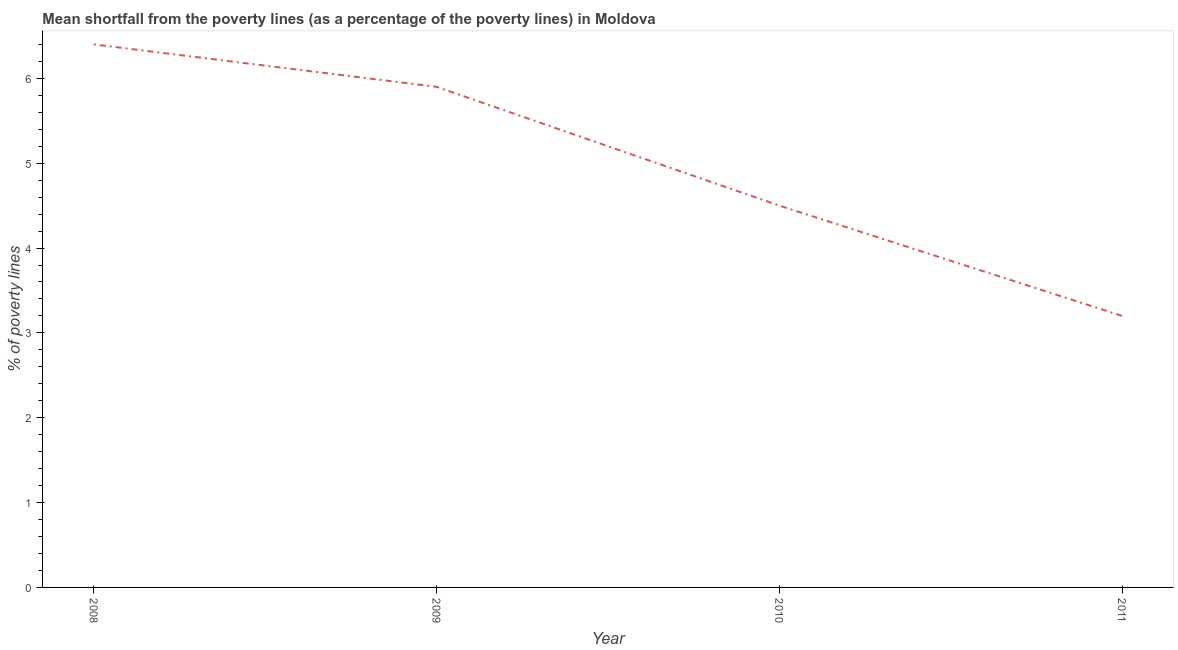What is the poverty gap at national poverty lines in 2010?
Make the answer very short. 4.5. What is the difference between the poverty gap at national poverty lines in 2008 and 2011?
Give a very brief answer. 3.2. What is the ratio of the poverty gap at national poverty lines in 2009 to that in 2010?
Your answer should be very brief. 1.31. Is the poverty gap at national poverty lines in 2008 less than that in 2010?
Offer a very short reply. No. Is the difference between the poverty gap at national poverty lines in 2008 and 2009 greater than the difference between any two years?
Provide a succinct answer. No. What is the difference between the highest and the lowest poverty gap at national poverty lines?
Provide a short and direct response. 3.2. Does the poverty gap at national poverty lines monotonically increase over the years?
Ensure brevity in your answer.  No. What is the difference between two consecutive major ticks on the Y-axis?
Keep it short and to the point. 1. Does the graph contain any zero values?
Keep it short and to the point. No. What is the title of the graph?
Ensure brevity in your answer.  Mean shortfall from the poverty lines (as a percentage of the poverty lines) in Moldova. What is the label or title of the Y-axis?
Your answer should be very brief. % of poverty lines. What is the % of poverty lines of 2008?
Ensure brevity in your answer.  6.4. What is the difference between the % of poverty lines in 2008 and 2009?
Provide a succinct answer. 0.5. What is the difference between the % of poverty lines in 2008 and 2010?
Provide a short and direct response. 1.9. What is the difference between the % of poverty lines in 2008 and 2011?
Your answer should be compact. 3.2. What is the ratio of the % of poverty lines in 2008 to that in 2009?
Offer a terse response. 1.08. What is the ratio of the % of poverty lines in 2008 to that in 2010?
Your answer should be very brief. 1.42. What is the ratio of the % of poverty lines in 2009 to that in 2010?
Your answer should be compact. 1.31. What is the ratio of the % of poverty lines in 2009 to that in 2011?
Ensure brevity in your answer.  1.84. What is the ratio of the % of poverty lines in 2010 to that in 2011?
Ensure brevity in your answer.  1.41. 